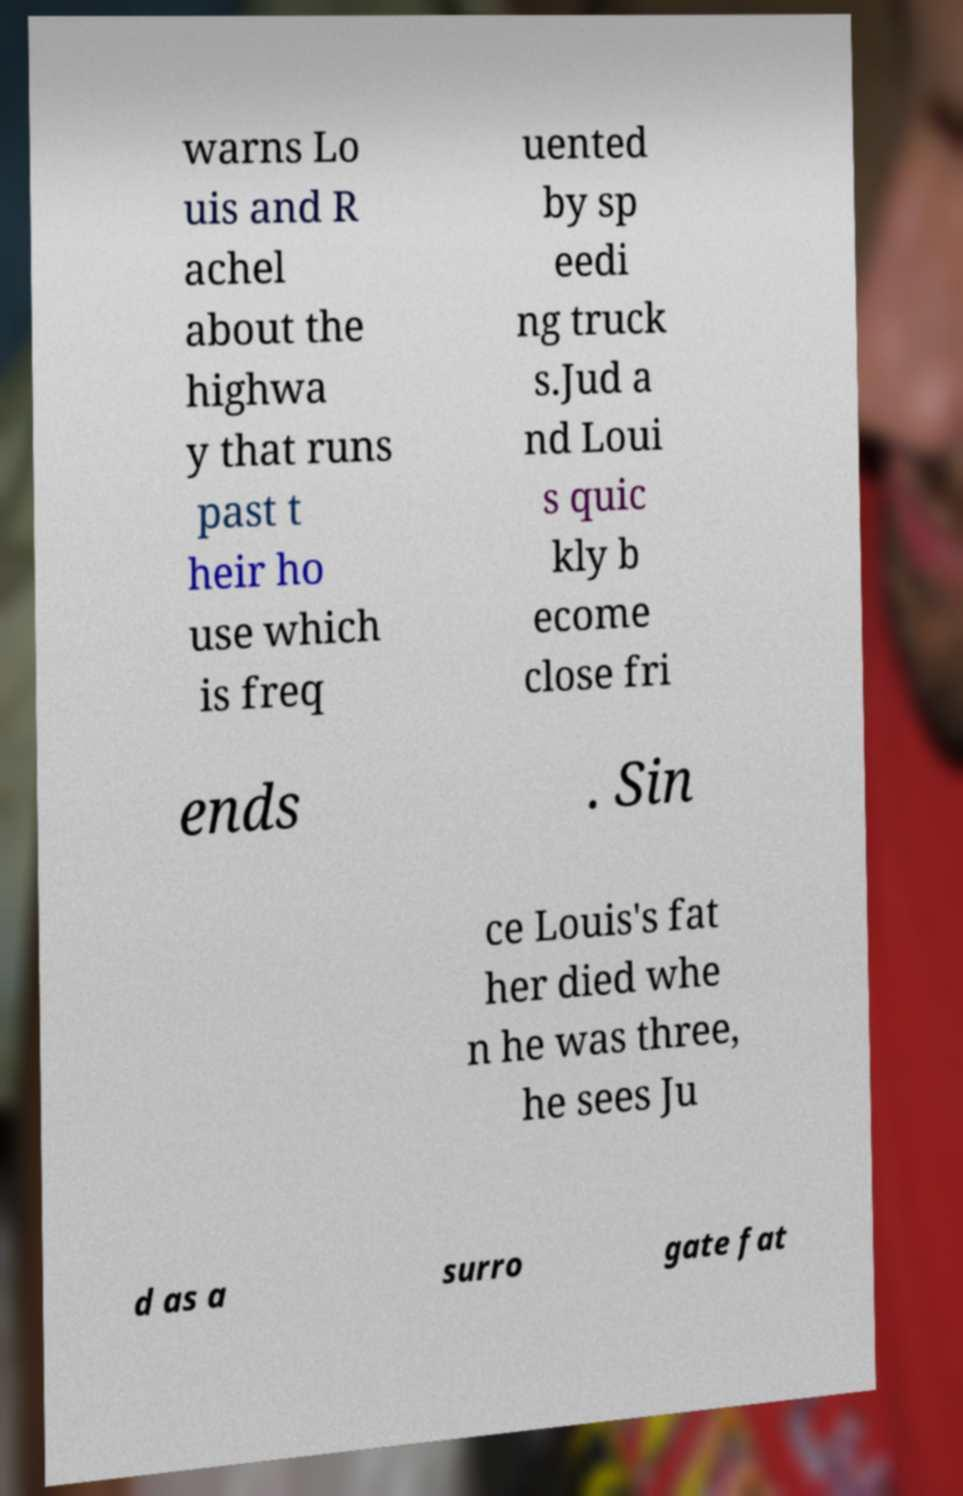Could you assist in decoding the text presented in this image and type it out clearly? warns Lo uis and R achel about the highwa y that runs past t heir ho use which is freq uented by sp eedi ng truck s.Jud a nd Loui s quic kly b ecome close fri ends . Sin ce Louis's fat her died whe n he was three, he sees Ju d as a surro gate fat 